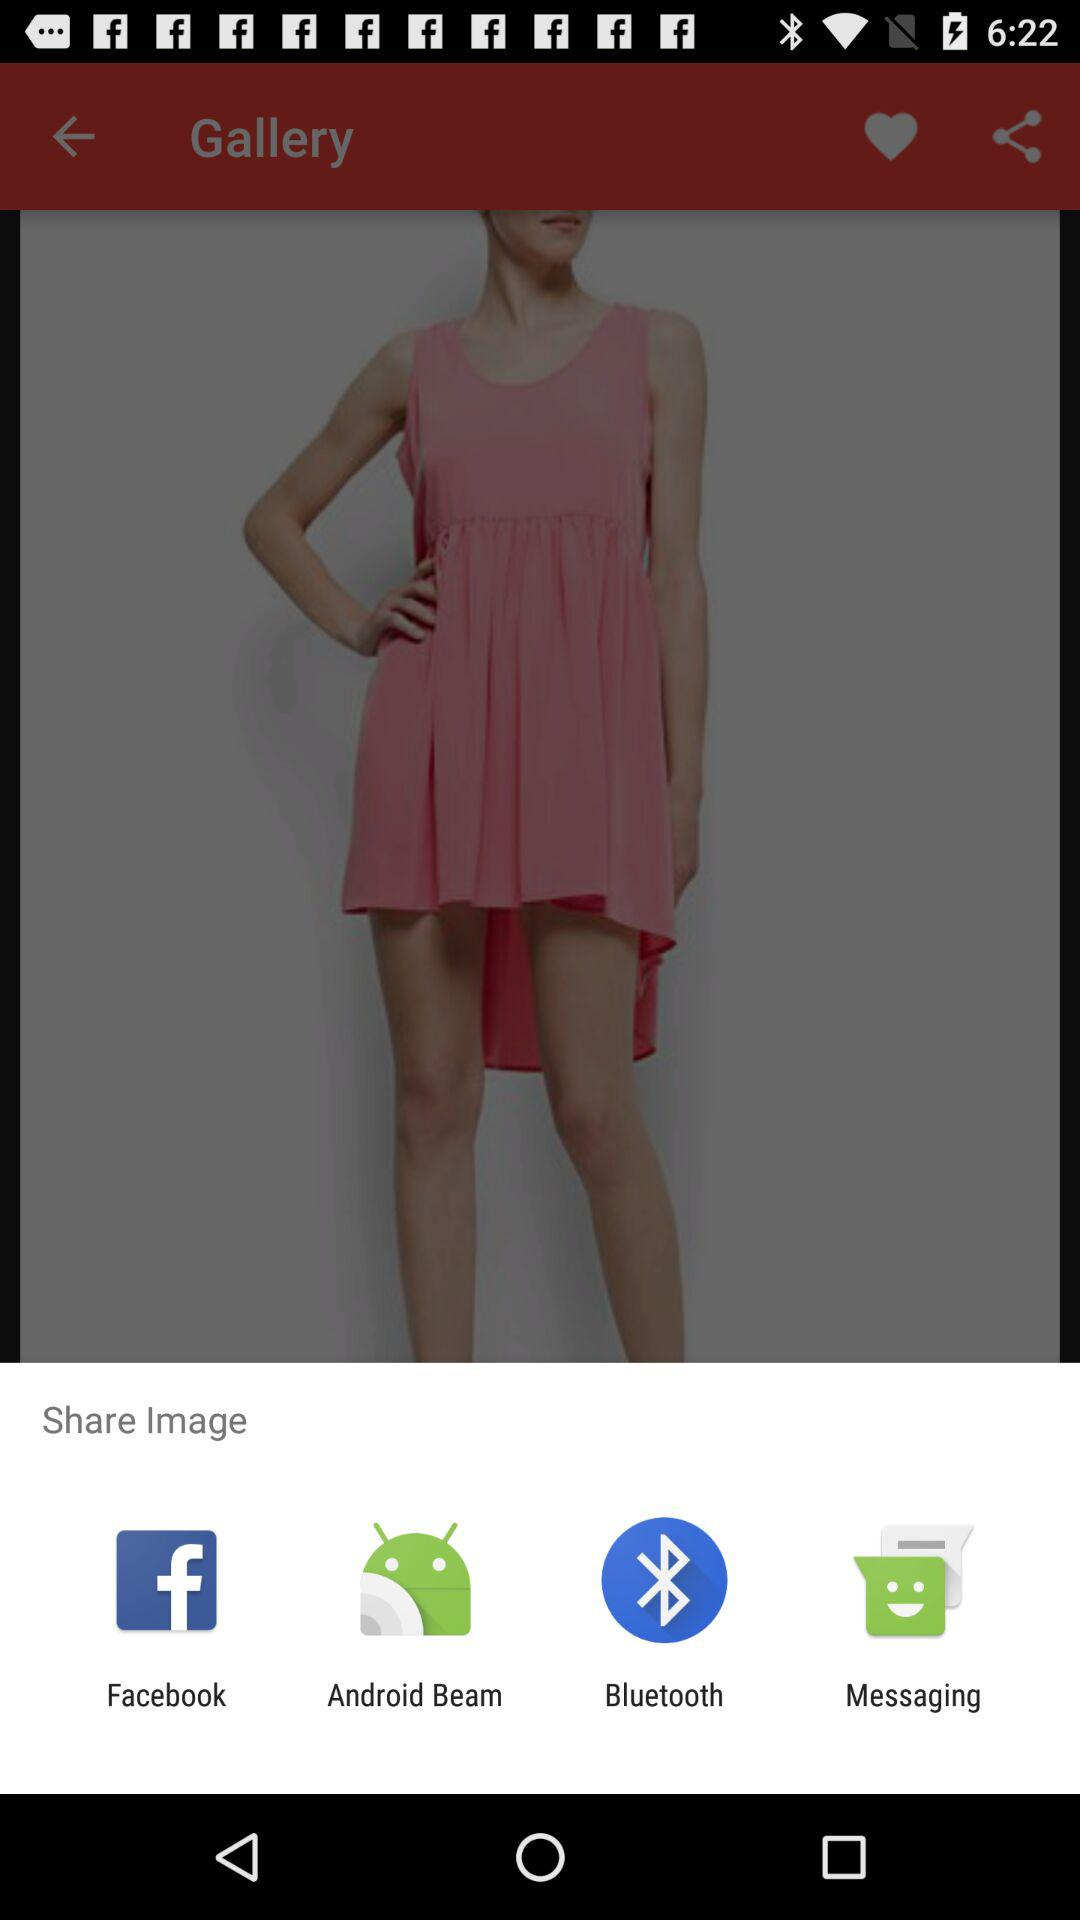What are the different applications through which we can share the image? The different applications through which we can share the image are "Facebook", "Android Beam", "Bluetooth" and "Messaging". 